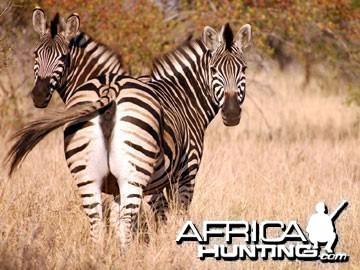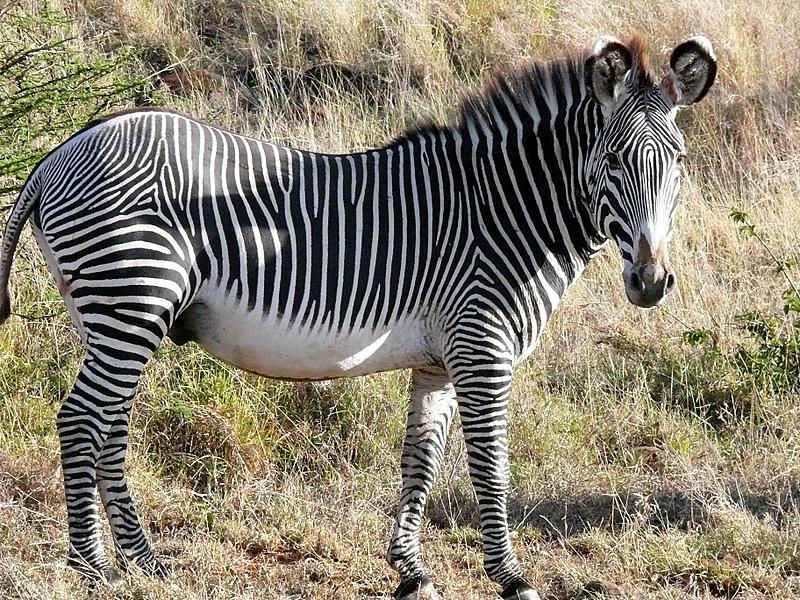The first image is the image on the left, the second image is the image on the right. For the images displayed, is the sentence "An image shows two zebras standing close together with their heads facing in opposite directions." factually correct? Answer yes or no. Yes. 